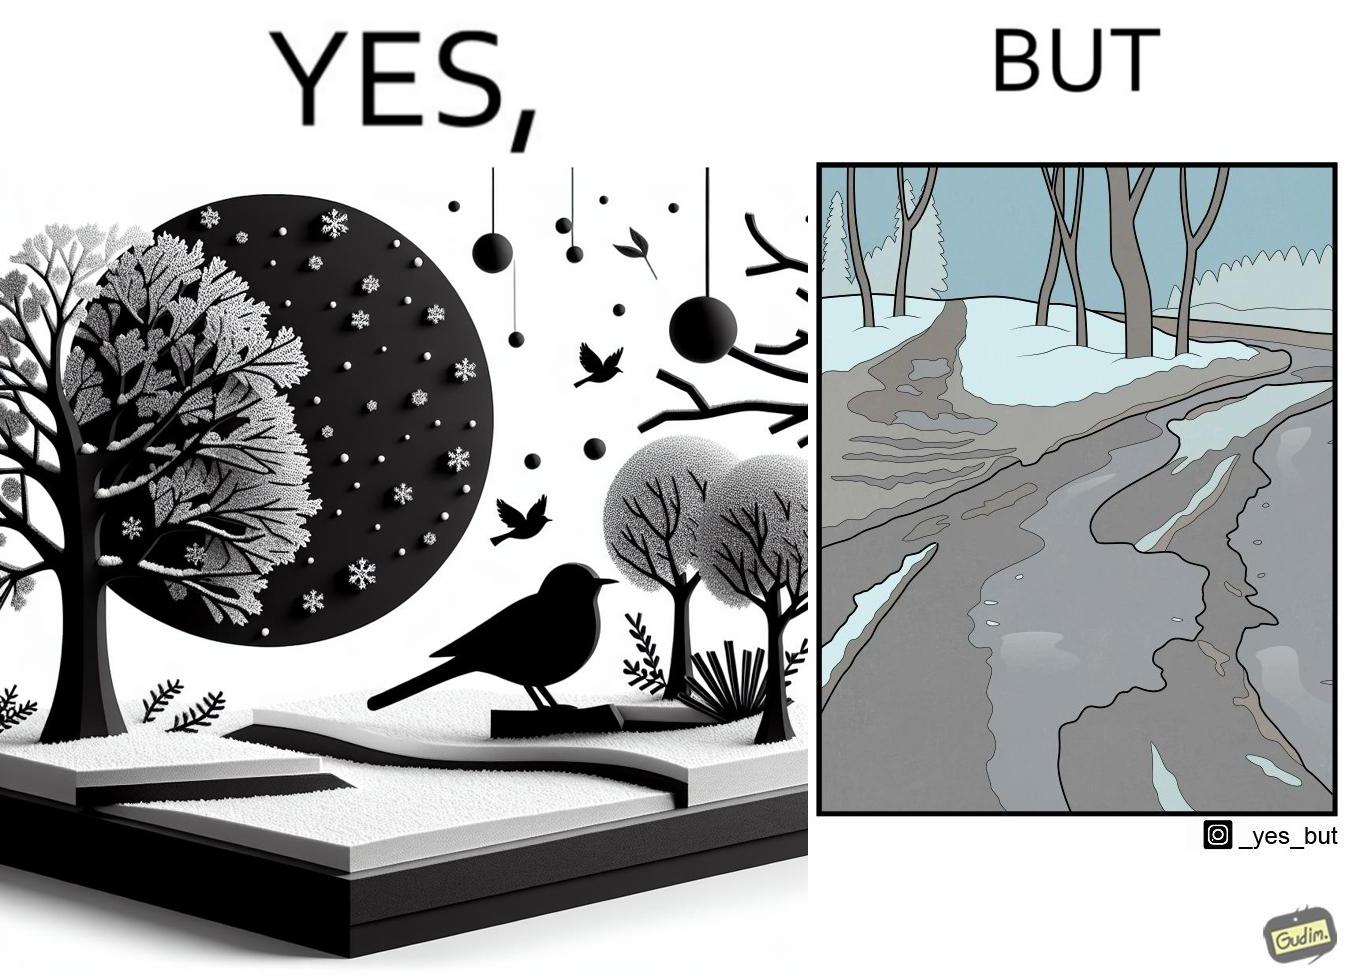Describe the contrast between the left and right parts of this image. In the left part of the image: Trees and ground covered by snow due to snowfall, with a bird resting on a branch, and the Sun in the sky. In the right part of the image: Snow covered trees, and the ground partially covered in snow. 